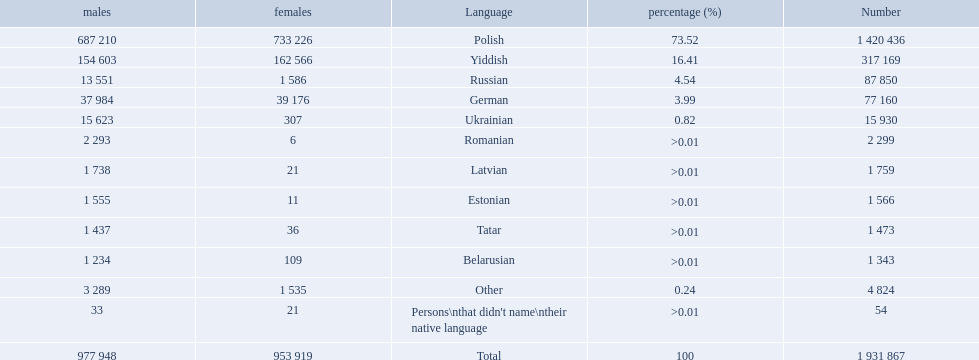What were all the languages? Polish, Yiddish, Russian, German, Ukrainian, Romanian, Latvian, Estonian, Tatar, Belarusian, Other, Persons\nthat didn't name\ntheir native language. For these, how many people spoke them? 1 420 436, 317 169, 87 850, 77 160, 15 930, 2 299, 1 759, 1 566, 1 473, 1 343, 4 824, 54. Of these, which is the largest number of speakers? 1 420 436. Which language corresponds to this number? Polish. What are all of the languages used in the warsaw governorate? Polish, Yiddish, Russian, German, Ukrainian, Romanian, Latvian, Estonian, Tatar, Belarusian, Other, Persons\nthat didn't name\ntheir native language. Which language was comprised of the least number of female speakers? Romanian. 